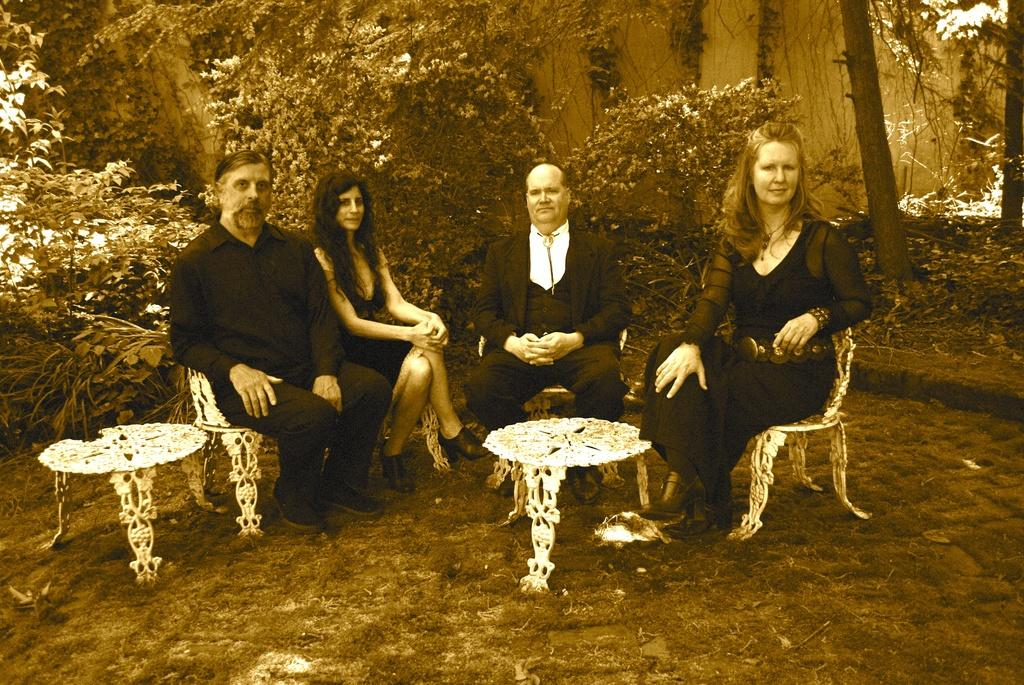How many people are in the image? There are four persons in the image. What are the persons doing in the image? The persons are sitting on chairs. What is present in the image besides the people? There is a table in the image. What can be seen in the background of the image? Trees are visible in the background of the image. What type of waste is being recycled by the persons in the image? There is no waste or recycling activity depicted in the image; the persons are simply sitting on chairs. 